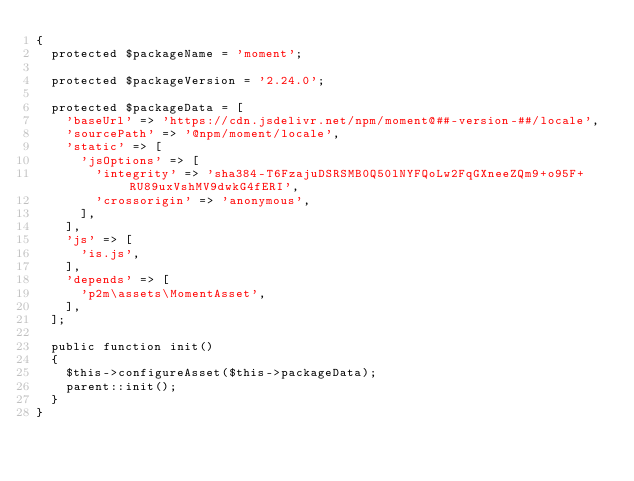<code> <loc_0><loc_0><loc_500><loc_500><_PHP_>{
	protected $packageName = 'moment';

	protected $packageVersion = '2.24.0';

	protected $packageData = [
		'baseUrl' => 'https://cdn.jsdelivr.net/npm/moment@##-version-##/locale',
		'sourcePath' => '@npm/moment/locale',
		'static' => [
			'jsOptions' => [
				'integrity' => 'sha384-T6FzajuDSRSMB0Q50lNYFQoLw2FqGXneeZQm9+o95F+RU89uxVshMV9dwkG4fERI',
				'crossorigin' => 'anonymous',
			],
		],
		'js' => [
			'is.js',
		],
		'depends' => [
			'p2m\assets\MomentAsset',
		],
	];

	public function init()
	{
		$this->configureAsset($this->packageData);
		parent::init();
	}
}
</code> 